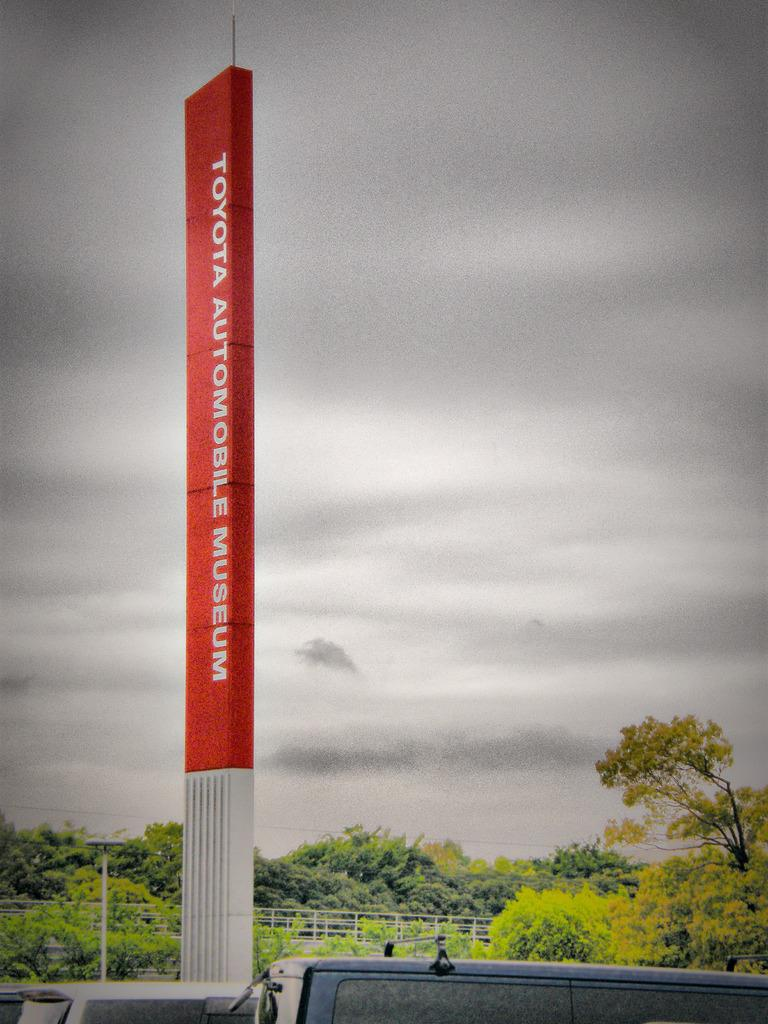<image>
Render a clear and concise summary of the photo. The large red sign is a sign for a museum for cars. 